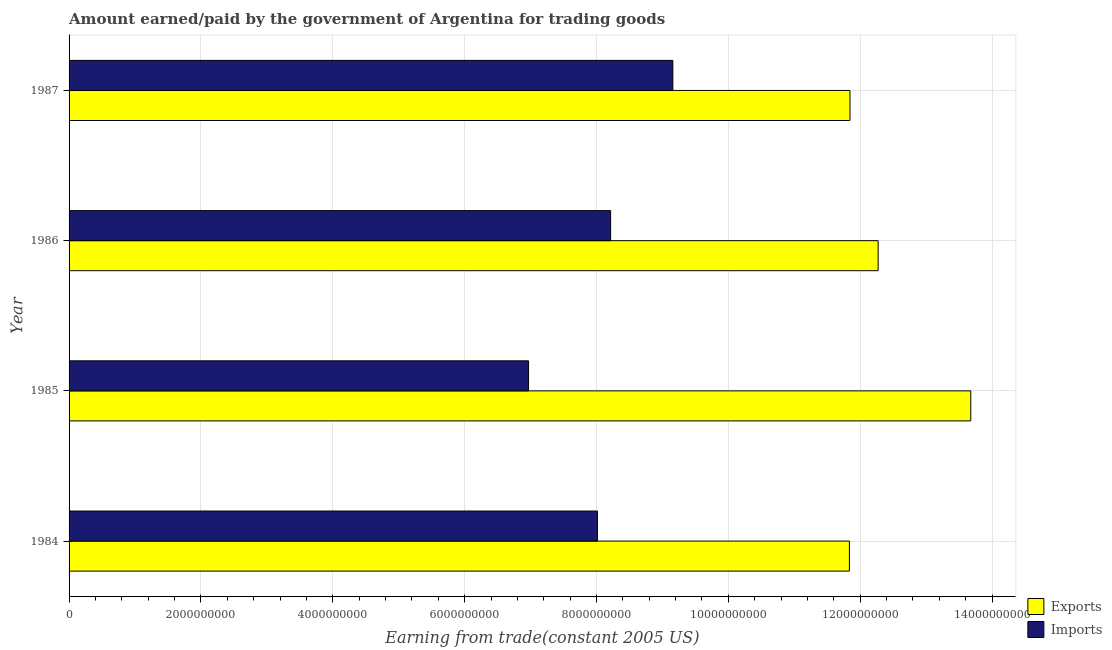Are the number of bars per tick equal to the number of legend labels?
Ensure brevity in your answer.  Yes. Are the number of bars on each tick of the Y-axis equal?
Provide a succinct answer. Yes. How many bars are there on the 1st tick from the bottom?
Offer a very short reply. 2. What is the amount paid for imports in 1987?
Your answer should be very brief. 9.16e+09. Across all years, what is the maximum amount earned from exports?
Your answer should be very brief. 1.37e+1. Across all years, what is the minimum amount earned from exports?
Give a very brief answer. 1.18e+1. In which year was the amount paid for imports maximum?
Your response must be concise. 1987. In which year was the amount paid for imports minimum?
Make the answer very short. 1985. What is the total amount earned from exports in the graph?
Your answer should be compact. 4.96e+1. What is the difference between the amount earned from exports in 1984 and that in 1986?
Make the answer very short. -4.36e+08. What is the difference between the amount paid for imports in 1984 and the amount earned from exports in 1987?
Offer a terse response. -3.83e+09. What is the average amount earned from exports per year?
Provide a short and direct response. 1.24e+1. In the year 1986, what is the difference between the amount paid for imports and amount earned from exports?
Offer a very short reply. -4.06e+09. In how many years, is the amount earned from exports greater than 8400000000 US$?
Provide a short and direct response. 4. What is the ratio of the amount earned from exports in 1984 to that in 1985?
Offer a very short reply. 0.86. Is the difference between the amount earned from exports in 1984 and 1987 greater than the difference between the amount paid for imports in 1984 and 1987?
Offer a terse response. Yes. What is the difference between the highest and the second highest amount paid for imports?
Provide a succinct answer. 9.43e+08. What is the difference between the highest and the lowest amount earned from exports?
Your answer should be compact. 1.84e+09. Is the sum of the amount paid for imports in 1984 and 1986 greater than the maximum amount earned from exports across all years?
Your answer should be very brief. Yes. What does the 2nd bar from the top in 1985 represents?
Keep it short and to the point. Exports. What does the 1st bar from the bottom in 1984 represents?
Provide a short and direct response. Exports. How many bars are there?
Give a very brief answer. 8. What is the difference between two consecutive major ticks on the X-axis?
Your response must be concise. 2.00e+09. Are the values on the major ticks of X-axis written in scientific E-notation?
Give a very brief answer. No. Does the graph contain grids?
Offer a terse response. Yes. What is the title of the graph?
Your answer should be very brief. Amount earned/paid by the government of Argentina for trading goods. What is the label or title of the X-axis?
Keep it short and to the point. Earning from trade(constant 2005 US). What is the label or title of the Y-axis?
Offer a terse response. Year. What is the Earning from trade(constant 2005 US) in Exports in 1984?
Give a very brief answer. 1.18e+1. What is the Earning from trade(constant 2005 US) in Imports in 1984?
Offer a very short reply. 8.01e+09. What is the Earning from trade(constant 2005 US) in Exports in 1985?
Your answer should be very brief. 1.37e+1. What is the Earning from trade(constant 2005 US) of Imports in 1985?
Your response must be concise. 6.97e+09. What is the Earning from trade(constant 2005 US) of Exports in 1986?
Offer a very short reply. 1.23e+1. What is the Earning from trade(constant 2005 US) of Imports in 1986?
Provide a short and direct response. 8.21e+09. What is the Earning from trade(constant 2005 US) of Exports in 1987?
Offer a terse response. 1.18e+1. What is the Earning from trade(constant 2005 US) in Imports in 1987?
Offer a very short reply. 9.16e+09. Across all years, what is the maximum Earning from trade(constant 2005 US) in Exports?
Your response must be concise. 1.37e+1. Across all years, what is the maximum Earning from trade(constant 2005 US) in Imports?
Give a very brief answer. 9.16e+09. Across all years, what is the minimum Earning from trade(constant 2005 US) of Exports?
Give a very brief answer. 1.18e+1. Across all years, what is the minimum Earning from trade(constant 2005 US) in Imports?
Your answer should be compact. 6.97e+09. What is the total Earning from trade(constant 2005 US) in Exports in the graph?
Provide a succinct answer. 4.96e+1. What is the total Earning from trade(constant 2005 US) of Imports in the graph?
Offer a terse response. 3.24e+1. What is the difference between the Earning from trade(constant 2005 US) of Exports in 1984 and that in 1985?
Offer a very short reply. -1.84e+09. What is the difference between the Earning from trade(constant 2005 US) in Imports in 1984 and that in 1985?
Provide a short and direct response. 1.04e+09. What is the difference between the Earning from trade(constant 2005 US) in Exports in 1984 and that in 1986?
Your answer should be compact. -4.36e+08. What is the difference between the Earning from trade(constant 2005 US) of Imports in 1984 and that in 1986?
Offer a very short reply. -2.00e+08. What is the difference between the Earning from trade(constant 2005 US) in Exports in 1984 and that in 1987?
Offer a terse response. -8.98e+06. What is the difference between the Earning from trade(constant 2005 US) in Imports in 1984 and that in 1987?
Offer a very short reply. -1.14e+09. What is the difference between the Earning from trade(constant 2005 US) of Exports in 1985 and that in 1986?
Ensure brevity in your answer.  1.40e+09. What is the difference between the Earning from trade(constant 2005 US) of Imports in 1985 and that in 1986?
Provide a succinct answer. -1.25e+09. What is the difference between the Earning from trade(constant 2005 US) in Exports in 1985 and that in 1987?
Provide a short and direct response. 1.83e+09. What is the difference between the Earning from trade(constant 2005 US) of Imports in 1985 and that in 1987?
Provide a succinct answer. -2.19e+09. What is the difference between the Earning from trade(constant 2005 US) in Exports in 1986 and that in 1987?
Make the answer very short. 4.27e+08. What is the difference between the Earning from trade(constant 2005 US) in Imports in 1986 and that in 1987?
Provide a succinct answer. -9.43e+08. What is the difference between the Earning from trade(constant 2005 US) of Exports in 1984 and the Earning from trade(constant 2005 US) of Imports in 1985?
Ensure brevity in your answer.  4.87e+09. What is the difference between the Earning from trade(constant 2005 US) of Exports in 1984 and the Earning from trade(constant 2005 US) of Imports in 1986?
Ensure brevity in your answer.  3.62e+09. What is the difference between the Earning from trade(constant 2005 US) of Exports in 1984 and the Earning from trade(constant 2005 US) of Imports in 1987?
Ensure brevity in your answer.  2.68e+09. What is the difference between the Earning from trade(constant 2005 US) of Exports in 1985 and the Earning from trade(constant 2005 US) of Imports in 1986?
Offer a very short reply. 5.46e+09. What is the difference between the Earning from trade(constant 2005 US) of Exports in 1985 and the Earning from trade(constant 2005 US) of Imports in 1987?
Your answer should be compact. 4.52e+09. What is the difference between the Earning from trade(constant 2005 US) of Exports in 1986 and the Earning from trade(constant 2005 US) of Imports in 1987?
Your response must be concise. 3.11e+09. What is the average Earning from trade(constant 2005 US) in Exports per year?
Give a very brief answer. 1.24e+1. What is the average Earning from trade(constant 2005 US) in Imports per year?
Make the answer very short. 8.09e+09. In the year 1984, what is the difference between the Earning from trade(constant 2005 US) in Exports and Earning from trade(constant 2005 US) in Imports?
Make the answer very short. 3.82e+09. In the year 1985, what is the difference between the Earning from trade(constant 2005 US) in Exports and Earning from trade(constant 2005 US) in Imports?
Keep it short and to the point. 6.71e+09. In the year 1986, what is the difference between the Earning from trade(constant 2005 US) of Exports and Earning from trade(constant 2005 US) of Imports?
Offer a terse response. 4.06e+09. In the year 1987, what is the difference between the Earning from trade(constant 2005 US) in Exports and Earning from trade(constant 2005 US) in Imports?
Your answer should be very brief. 2.69e+09. What is the ratio of the Earning from trade(constant 2005 US) in Exports in 1984 to that in 1985?
Ensure brevity in your answer.  0.87. What is the ratio of the Earning from trade(constant 2005 US) of Imports in 1984 to that in 1985?
Provide a succinct answer. 1.15. What is the ratio of the Earning from trade(constant 2005 US) in Exports in 1984 to that in 1986?
Your response must be concise. 0.96. What is the ratio of the Earning from trade(constant 2005 US) in Imports in 1984 to that in 1986?
Your answer should be compact. 0.98. What is the ratio of the Earning from trade(constant 2005 US) of Imports in 1984 to that in 1987?
Provide a short and direct response. 0.88. What is the ratio of the Earning from trade(constant 2005 US) of Exports in 1985 to that in 1986?
Keep it short and to the point. 1.11. What is the ratio of the Earning from trade(constant 2005 US) of Imports in 1985 to that in 1986?
Your answer should be compact. 0.85. What is the ratio of the Earning from trade(constant 2005 US) in Exports in 1985 to that in 1987?
Keep it short and to the point. 1.15. What is the ratio of the Earning from trade(constant 2005 US) of Imports in 1985 to that in 1987?
Offer a terse response. 0.76. What is the ratio of the Earning from trade(constant 2005 US) of Exports in 1986 to that in 1987?
Give a very brief answer. 1.04. What is the ratio of the Earning from trade(constant 2005 US) in Imports in 1986 to that in 1987?
Make the answer very short. 0.9. What is the difference between the highest and the second highest Earning from trade(constant 2005 US) of Exports?
Make the answer very short. 1.40e+09. What is the difference between the highest and the second highest Earning from trade(constant 2005 US) in Imports?
Keep it short and to the point. 9.43e+08. What is the difference between the highest and the lowest Earning from trade(constant 2005 US) in Exports?
Your response must be concise. 1.84e+09. What is the difference between the highest and the lowest Earning from trade(constant 2005 US) of Imports?
Your answer should be very brief. 2.19e+09. 